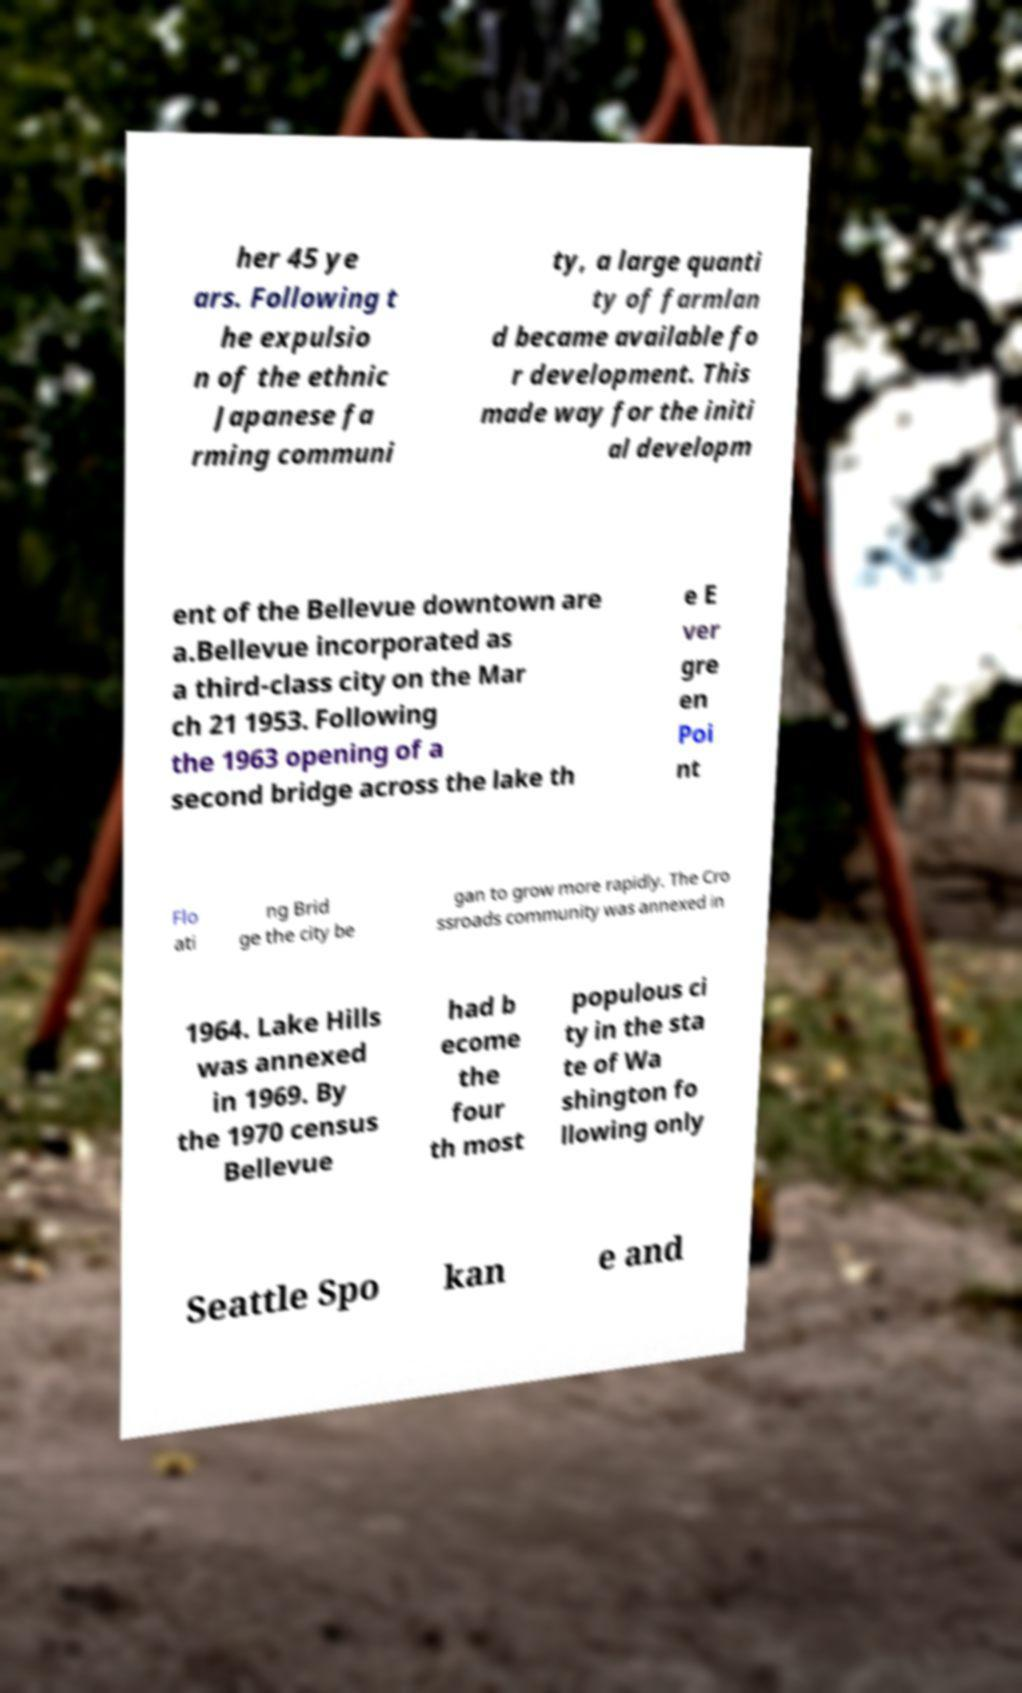Please read and relay the text visible in this image. What does it say? her 45 ye ars. Following t he expulsio n of the ethnic Japanese fa rming communi ty, a large quanti ty of farmlan d became available fo r development. This made way for the initi al developm ent of the Bellevue downtown are a.Bellevue incorporated as a third-class city on the Mar ch 21 1953. Following the 1963 opening of a second bridge across the lake th e E ver gre en Poi nt Flo ati ng Brid ge the city be gan to grow more rapidly. The Cro ssroads community was annexed in 1964. Lake Hills was annexed in 1969. By the 1970 census Bellevue had b ecome the four th most populous ci ty in the sta te of Wa shington fo llowing only Seattle Spo kan e and 